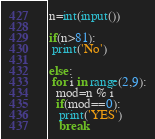Convert code to text. <code><loc_0><loc_0><loc_500><loc_500><_Python_>n=int(input())

if(n>81):
 print('No')
 
else:
 for i in range(2,9):
  mod=n % i
  if(mod==0):
   print('YES')
   break</code> 